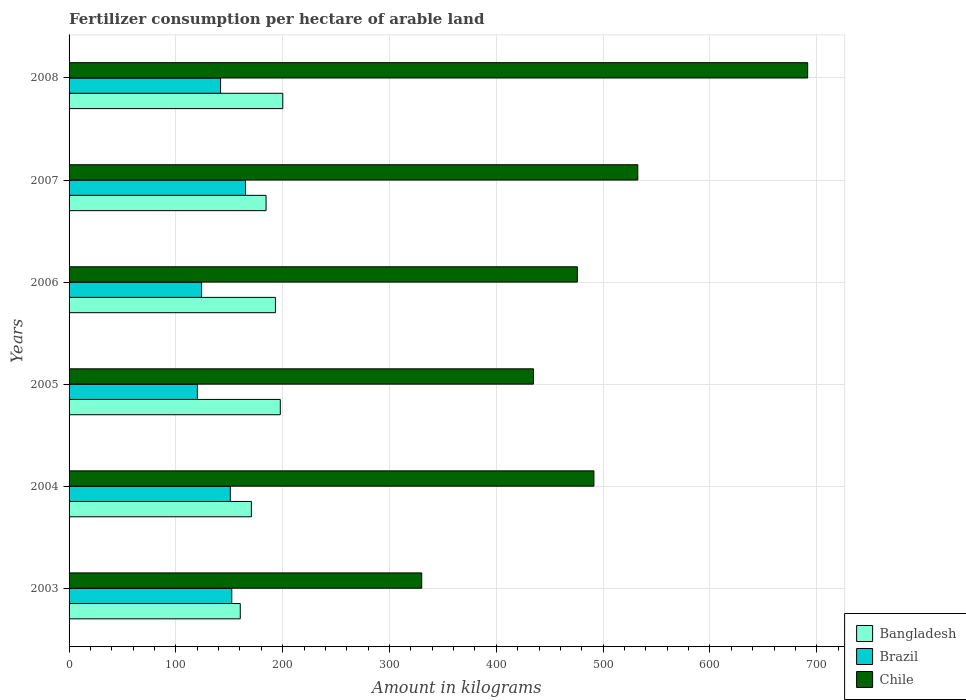How many different coloured bars are there?
Provide a succinct answer. 3. How many groups of bars are there?
Your answer should be very brief. 6. How many bars are there on the 6th tick from the top?
Your response must be concise. 3. What is the label of the 4th group of bars from the top?
Make the answer very short. 2005. What is the amount of fertilizer consumption in Bangladesh in 2004?
Offer a very short reply. 170.67. Across all years, what is the maximum amount of fertilizer consumption in Chile?
Provide a short and direct response. 691.46. Across all years, what is the minimum amount of fertilizer consumption in Chile?
Ensure brevity in your answer.  330.14. In which year was the amount of fertilizer consumption in Brazil maximum?
Your response must be concise. 2007. What is the total amount of fertilizer consumption in Brazil in the graph?
Give a very brief answer. 854.39. What is the difference between the amount of fertilizer consumption in Chile in 2003 and that in 2008?
Make the answer very short. -361.31. What is the difference between the amount of fertilizer consumption in Chile in 2004 and the amount of fertilizer consumption in Brazil in 2003?
Keep it short and to the point. 339.05. What is the average amount of fertilizer consumption in Chile per year?
Offer a terse response. 492.66. In the year 2008, what is the difference between the amount of fertilizer consumption in Bangladesh and amount of fertilizer consumption in Chile?
Your answer should be compact. -491.39. In how many years, is the amount of fertilizer consumption in Brazil greater than 140 kg?
Offer a terse response. 4. What is the ratio of the amount of fertilizer consumption in Chile in 2006 to that in 2007?
Offer a terse response. 0.89. Is the amount of fertilizer consumption in Chile in 2006 less than that in 2008?
Offer a very short reply. Yes. Is the difference between the amount of fertilizer consumption in Bangladesh in 2006 and 2008 greater than the difference between the amount of fertilizer consumption in Chile in 2006 and 2008?
Give a very brief answer. Yes. What is the difference between the highest and the second highest amount of fertilizer consumption in Chile?
Give a very brief answer. 159.04. What is the difference between the highest and the lowest amount of fertilizer consumption in Chile?
Your answer should be compact. 361.31. In how many years, is the amount of fertilizer consumption in Brazil greater than the average amount of fertilizer consumption in Brazil taken over all years?
Provide a short and direct response. 3. What does the 3rd bar from the top in 2004 represents?
Your answer should be very brief. Bangladesh. What does the 2nd bar from the bottom in 2004 represents?
Your response must be concise. Brazil. Is it the case that in every year, the sum of the amount of fertilizer consumption in Brazil and amount of fertilizer consumption in Bangladesh is greater than the amount of fertilizer consumption in Chile?
Keep it short and to the point. No. How many bars are there?
Give a very brief answer. 18. Are all the bars in the graph horizontal?
Your response must be concise. Yes. How many years are there in the graph?
Ensure brevity in your answer.  6. Are the values on the major ticks of X-axis written in scientific E-notation?
Ensure brevity in your answer.  No. Does the graph contain grids?
Your answer should be compact. Yes. Where does the legend appear in the graph?
Your response must be concise. Bottom right. How many legend labels are there?
Make the answer very short. 3. How are the legend labels stacked?
Your response must be concise. Vertical. What is the title of the graph?
Your response must be concise. Fertilizer consumption per hectare of arable land. What is the label or title of the X-axis?
Your response must be concise. Amount in kilograms. What is the label or title of the Y-axis?
Give a very brief answer. Years. What is the Amount in kilograms in Bangladesh in 2003?
Provide a succinct answer. 160.27. What is the Amount in kilograms of Brazil in 2003?
Provide a succinct answer. 152.31. What is the Amount in kilograms of Chile in 2003?
Your answer should be very brief. 330.14. What is the Amount in kilograms of Bangladesh in 2004?
Ensure brevity in your answer.  170.67. What is the Amount in kilograms of Brazil in 2004?
Make the answer very short. 150.95. What is the Amount in kilograms of Chile in 2004?
Keep it short and to the point. 491.35. What is the Amount in kilograms in Bangladesh in 2005?
Offer a very short reply. 197.75. What is the Amount in kilograms of Brazil in 2005?
Your response must be concise. 120.1. What is the Amount in kilograms of Chile in 2005?
Keep it short and to the point. 434.76. What is the Amount in kilograms of Bangladesh in 2006?
Give a very brief answer. 193.19. What is the Amount in kilograms of Brazil in 2006?
Give a very brief answer. 124.03. What is the Amount in kilograms in Chile in 2006?
Your response must be concise. 475.81. What is the Amount in kilograms in Bangladesh in 2007?
Keep it short and to the point. 184.41. What is the Amount in kilograms of Brazil in 2007?
Provide a short and direct response. 165.17. What is the Amount in kilograms in Chile in 2007?
Keep it short and to the point. 532.41. What is the Amount in kilograms in Bangladesh in 2008?
Keep it short and to the point. 200.06. What is the Amount in kilograms in Brazil in 2008?
Make the answer very short. 141.84. What is the Amount in kilograms of Chile in 2008?
Provide a short and direct response. 691.46. Across all years, what is the maximum Amount in kilograms in Bangladesh?
Give a very brief answer. 200.06. Across all years, what is the maximum Amount in kilograms in Brazil?
Your answer should be very brief. 165.17. Across all years, what is the maximum Amount in kilograms of Chile?
Give a very brief answer. 691.46. Across all years, what is the minimum Amount in kilograms in Bangladesh?
Your answer should be very brief. 160.27. Across all years, what is the minimum Amount in kilograms in Brazil?
Give a very brief answer. 120.1. Across all years, what is the minimum Amount in kilograms in Chile?
Keep it short and to the point. 330.14. What is the total Amount in kilograms in Bangladesh in the graph?
Offer a terse response. 1106.35. What is the total Amount in kilograms in Brazil in the graph?
Offer a terse response. 854.39. What is the total Amount in kilograms in Chile in the graph?
Your answer should be compact. 2955.94. What is the difference between the Amount in kilograms of Bangladesh in 2003 and that in 2004?
Offer a very short reply. -10.4. What is the difference between the Amount in kilograms in Brazil in 2003 and that in 2004?
Your answer should be very brief. 1.36. What is the difference between the Amount in kilograms of Chile in 2003 and that in 2004?
Offer a terse response. -161.21. What is the difference between the Amount in kilograms in Bangladesh in 2003 and that in 2005?
Provide a short and direct response. -37.48. What is the difference between the Amount in kilograms of Brazil in 2003 and that in 2005?
Provide a succinct answer. 32.2. What is the difference between the Amount in kilograms of Chile in 2003 and that in 2005?
Your answer should be compact. -104.62. What is the difference between the Amount in kilograms of Bangladesh in 2003 and that in 2006?
Your answer should be compact. -32.92. What is the difference between the Amount in kilograms in Brazil in 2003 and that in 2006?
Your answer should be compact. 28.27. What is the difference between the Amount in kilograms in Chile in 2003 and that in 2006?
Keep it short and to the point. -145.67. What is the difference between the Amount in kilograms in Bangladesh in 2003 and that in 2007?
Make the answer very short. -24.14. What is the difference between the Amount in kilograms of Brazil in 2003 and that in 2007?
Keep it short and to the point. -12.86. What is the difference between the Amount in kilograms of Chile in 2003 and that in 2007?
Make the answer very short. -202.27. What is the difference between the Amount in kilograms of Bangladesh in 2003 and that in 2008?
Provide a short and direct response. -39.8. What is the difference between the Amount in kilograms of Brazil in 2003 and that in 2008?
Ensure brevity in your answer.  10.47. What is the difference between the Amount in kilograms of Chile in 2003 and that in 2008?
Keep it short and to the point. -361.31. What is the difference between the Amount in kilograms of Bangladesh in 2004 and that in 2005?
Provide a short and direct response. -27.08. What is the difference between the Amount in kilograms in Brazil in 2004 and that in 2005?
Offer a very short reply. 30.85. What is the difference between the Amount in kilograms in Chile in 2004 and that in 2005?
Your response must be concise. 56.59. What is the difference between the Amount in kilograms of Bangladesh in 2004 and that in 2006?
Your answer should be very brief. -22.52. What is the difference between the Amount in kilograms of Brazil in 2004 and that in 2006?
Your answer should be compact. 26.91. What is the difference between the Amount in kilograms of Chile in 2004 and that in 2006?
Give a very brief answer. 15.54. What is the difference between the Amount in kilograms of Bangladesh in 2004 and that in 2007?
Your response must be concise. -13.74. What is the difference between the Amount in kilograms in Brazil in 2004 and that in 2007?
Provide a succinct answer. -14.22. What is the difference between the Amount in kilograms in Chile in 2004 and that in 2007?
Make the answer very short. -41.06. What is the difference between the Amount in kilograms in Bangladesh in 2004 and that in 2008?
Offer a very short reply. -29.39. What is the difference between the Amount in kilograms in Brazil in 2004 and that in 2008?
Offer a very short reply. 9.11. What is the difference between the Amount in kilograms of Chile in 2004 and that in 2008?
Your response must be concise. -200.1. What is the difference between the Amount in kilograms of Bangladesh in 2005 and that in 2006?
Your answer should be compact. 4.56. What is the difference between the Amount in kilograms in Brazil in 2005 and that in 2006?
Ensure brevity in your answer.  -3.93. What is the difference between the Amount in kilograms in Chile in 2005 and that in 2006?
Ensure brevity in your answer.  -41.05. What is the difference between the Amount in kilograms of Bangladesh in 2005 and that in 2007?
Give a very brief answer. 13.34. What is the difference between the Amount in kilograms of Brazil in 2005 and that in 2007?
Ensure brevity in your answer.  -45.07. What is the difference between the Amount in kilograms in Chile in 2005 and that in 2007?
Make the answer very short. -97.65. What is the difference between the Amount in kilograms of Bangladesh in 2005 and that in 2008?
Give a very brief answer. -2.32. What is the difference between the Amount in kilograms of Brazil in 2005 and that in 2008?
Offer a very short reply. -21.74. What is the difference between the Amount in kilograms in Chile in 2005 and that in 2008?
Offer a terse response. -256.69. What is the difference between the Amount in kilograms in Bangladesh in 2006 and that in 2007?
Offer a terse response. 8.78. What is the difference between the Amount in kilograms in Brazil in 2006 and that in 2007?
Make the answer very short. -41.14. What is the difference between the Amount in kilograms of Chile in 2006 and that in 2007?
Your answer should be very brief. -56.6. What is the difference between the Amount in kilograms in Bangladesh in 2006 and that in 2008?
Offer a very short reply. -6.87. What is the difference between the Amount in kilograms of Brazil in 2006 and that in 2008?
Offer a very short reply. -17.81. What is the difference between the Amount in kilograms of Chile in 2006 and that in 2008?
Keep it short and to the point. -215.64. What is the difference between the Amount in kilograms of Bangladesh in 2007 and that in 2008?
Make the answer very short. -15.65. What is the difference between the Amount in kilograms in Brazil in 2007 and that in 2008?
Your response must be concise. 23.33. What is the difference between the Amount in kilograms in Chile in 2007 and that in 2008?
Your response must be concise. -159.04. What is the difference between the Amount in kilograms in Bangladesh in 2003 and the Amount in kilograms in Brazil in 2004?
Your response must be concise. 9.32. What is the difference between the Amount in kilograms in Bangladesh in 2003 and the Amount in kilograms in Chile in 2004?
Your answer should be very brief. -331.09. What is the difference between the Amount in kilograms of Brazil in 2003 and the Amount in kilograms of Chile in 2004?
Offer a terse response. -339.05. What is the difference between the Amount in kilograms in Bangladesh in 2003 and the Amount in kilograms in Brazil in 2005?
Provide a succinct answer. 40.17. What is the difference between the Amount in kilograms of Bangladesh in 2003 and the Amount in kilograms of Chile in 2005?
Give a very brief answer. -274.49. What is the difference between the Amount in kilograms in Brazil in 2003 and the Amount in kilograms in Chile in 2005?
Your answer should be very brief. -282.46. What is the difference between the Amount in kilograms in Bangladesh in 2003 and the Amount in kilograms in Brazil in 2006?
Provide a succinct answer. 36.23. What is the difference between the Amount in kilograms of Bangladesh in 2003 and the Amount in kilograms of Chile in 2006?
Your answer should be compact. -315.55. What is the difference between the Amount in kilograms in Brazil in 2003 and the Amount in kilograms in Chile in 2006?
Provide a succinct answer. -323.51. What is the difference between the Amount in kilograms of Bangladesh in 2003 and the Amount in kilograms of Brazil in 2007?
Offer a very short reply. -4.9. What is the difference between the Amount in kilograms of Bangladesh in 2003 and the Amount in kilograms of Chile in 2007?
Keep it short and to the point. -372.15. What is the difference between the Amount in kilograms of Brazil in 2003 and the Amount in kilograms of Chile in 2007?
Give a very brief answer. -380.11. What is the difference between the Amount in kilograms of Bangladesh in 2003 and the Amount in kilograms of Brazil in 2008?
Ensure brevity in your answer.  18.43. What is the difference between the Amount in kilograms in Bangladesh in 2003 and the Amount in kilograms in Chile in 2008?
Provide a short and direct response. -531.19. What is the difference between the Amount in kilograms of Brazil in 2003 and the Amount in kilograms of Chile in 2008?
Provide a short and direct response. -539.15. What is the difference between the Amount in kilograms in Bangladesh in 2004 and the Amount in kilograms in Brazil in 2005?
Provide a short and direct response. 50.57. What is the difference between the Amount in kilograms of Bangladesh in 2004 and the Amount in kilograms of Chile in 2005?
Ensure brevity in your answer.  -264.09. What is the difference between the Amount in kilograms in Brazil in 2004 and the Amount in kilograms in Chile in 2005?
Offer a terse response. -283.82. What is the difference between the Amount in kilograms of Bangladesh in 2004 and the Amount in kilograms of Brazil in 2006?
Give a very brief answer. 46.64. What is the difference between the Amount in kilograms of Bangladesh in 2004 and the Amount in kilograms of Chile in 2006?
Provide a short and direct response. -305.14. What is the difference between the Amount in kilograms of Brazil in 2004 and the Amount in kilograms of Chile in 2006?
Provide a short and direct response. -324.87. What is the difference between the Amount in kilograms in Bangladesh in 2004 and the Amount in kilograms in Brazil in 2007?
Ensure brevity in your answer.  5.5. What is the difference between the Amount in kilograms of Bangladesh in 2004 and the Amount in kilograms of Chile in 2007?
Keep it short and to the point. -361.74. What is the difference between the Amount in kilograms of Brazil in 2004 and the Amount in kilograms of Chile in 2007?
Offer a terse response. -381.47. What is the difference between the Amount in kilograms of Bangladesh in 2004 and the Amount in kilograms of Brazil in 2008?
Give a very brief answer. 28.83. What is the difference between the Amount in kilograms of Bangladesh in 2004 and the Amount in kilograms of Chile in 2008?
Ensure brevity in your answer.  -520.78. What is the difference between the Amount in kilograms in Brazil in 2004 and the Amount in kilograms in Chile in 2008?
Your answer should be very brief. -540.51. What is the difference between the Amount in kilograms in Bangladesh in 2005 and the Amount in kilograms in Brazil in 2006?
Ensure brevity in your answer.  73.72. What is the difference between the Amount in kilograms in Bangladesh in 2005 and the Amount in kilograms in Chile in 2006?
Give a very brief answer. -278.07. What is the difference between the Amount in kilograms in Brazil in 2005 and the Amount in kilograms in Chile in 2006?
Make the answer very short. -355.71. What is the difference between the Amount in kilograms in Bangladesh in 2005 and the Amount in kilograms in Brazil in 2007?
Your answer should be compact. 32.58. What is the difference between the Amount in kilograms in Bangladesh in 2005 and the Amount in kilograms in Chile in 2007?
Provide a succinct answer. -334.66. What is the difference between the Amount in kilograms in Brazil in 2005 and the Amount in kilograms in Chile in 2007?
Offer a terse response. -412.31. What is the difference between the Amount in kilograms of Bangladesh in 2005 and the Amount in kilograms of Brazil in 2008?
Offer a terse response. 55.91. What is the difference between the Amount in kilograms in Bangladesh in 2005 and the Amount in kilograms in Chile in 2008?
Provide a succinct answer. -493.71. What is the difference between the Amount in kilograms in Brazil in 2005 and the Amount in kilograms in Chile in 2008?
Make the answer very short. -571.36. What is the difference between the Amount in kilograms of Bangladesh in 2006 and the Amount in kilograms of Brazil in 2007?
Your answer should be compact. 28.02. What is the difference between the Amount in kilograms of Bangladesh in 2006 and the Amount in kilograms of Chile in 2007?
Your response must be concise. -339.22. What is the difference between the Amount in kilograms of Brazil in 2006 and the Amount in kilograms of Chile in 2007?
Make the answer very short. -408.38. What is the difference between the Amount in kilograms of Bangladesh in 2006 and the Amount in kilograms of Brazil in 2008?
Ensure brevity in your answer.  51.35. What is the difference between the Amount in kilograms of Bangladesh in 2006 and the Amount in kilograms of Chile in 2008?
Provide a short and direct response. -498.27. What is the difference between the Amount in kilograms of Brazil in 2006 and the Amount in kilograms of Chile in 2008?
Keep it short and to the point. -567.42. What is the difference between the Amount in kilograms in Bangladesh in 2007 and the Amount in kilograms in Brazil in 2008?
Give a very brief answer. 42.57. What is the difference between the Amount in kilograms of Bangladesh in 2007 and the Amount in kilograms of Chile in 2008?
Make the answer very short. -507.05. What is the difference between the Amount in kilograms of Brazil in 2007 and the Amount in kilograms of Chile in 2008?
Make the answer very short. -526.29. What is the average Amount in kilograms in Bangladesh per year?
Offer a very short reply. 184.39. What is the average Amount in kilograms in Brazil per year?
Give a very brief answer. 142.4. What is the average Amount in kilograms in Chile per year?
Provide a succinct answer. 492.66. In the year 2003, what is the difference between the Amount in kilograms in Bangladesh and Amount in kilograms in Brazil?
Keep it short and to the point. 7.96. In the year 2003, what is the difference between the Amount in kilograms in Bangladesh and Amount in kilograms in Chile?
Provide a succinct answer. -169.88. In the year 2003, what is the difference between the Amount in kilograms of Brazil and Amount in kilograms of Chile?
Offer a very short reply. -177.84. In the year 2004, what is the difference between the Amount in kilograms of Bangladesh and Amount in kilograms of Brazil?
Your answer should be very brief. 19.73. In the year 2004, what is the difference between the Amount in kilograms in Bangladesh and Amount in kilograms in Chile?
Offer a very short reply. -320.68. In the year 2004, what is the difference between the Amount in kilograms in Brazil and Amount in kilograms in Chile?
Keep it short and to the point. -340.41. In the year 2005, what is the difference between the Amount in kilograms in Bangladesh and Amount in kilograms in Brazil?
Offer a very short reply. 77.65. In the year 2005, what is the difference between the Amount in kilograms of Bangladesh and Amount in kilograms of Chile?
Offer a very short reply. -237.01. In the year 2005, what is the difference between the Amount in kilograms of Brazil and Amount in kilograms of Chile?
Your answer should be very brief. -314.66. In the year 2006, what is the difference between the Amount in kilograms of Bangladesh and Amount in kilograms of Brazil?
Ensure brevity in your answer.  69.16. In the year 2006, what is the difference between the Amount in kilograms in Bangladesh and Amount in kilograms in Chile?
Your answer should be very brief. -282.62. In the year 2006, what is the difference between the Amount in kilograms of Brazil and Amount in kilograms of Chile?
Provide a succinct answer. -351.78. In the year 2007, what is the difference between the Amount in kilograms of Bangladesh and Amount in kilograms of Brazil?
Your answer should be very brief. 19.24. In the year 2007, what is the difference between the Amount in kilograms of Bangladesh and Amount in kilograms of Chile?
Offer a very short reply. -348. In the year 2007, what is the difference between the Amount in kilograms in Brazil and Amount in kilograms in Chile?
Give a very brief answer. -367.24. In the year 2008, what is the difference between the Amount in kilograms in Bangladesh and Amount in kilograms in Brazil?
Provide a succinct answer. 58.23. In the year 2008, what is the difference between the Amount in kilograms of Bangladesh and Amount in kilograms of Chile?
Ensure brevity in your answer.  -491.39. In the year 2008, what is the difference between the Amount in kilograms of Brazil and Amount in kilograms of Chile?
Make the answer very short. -549.62. What is the ratio of the Amount in kilograms in Bangladesh in 2003 to that in 2004?
Keep it short and to the point. 0.94. What is the ratio of the Amount in kilograms in Chile in 2003 to that in 2004?
Make the answer very short. 0.67. What is the ratio of the Amount in kilograms in Bangladesh in 2003 to that in 2005?
Your response must be concise. 0.81. What is the ratio of the Amount in kilograms in Brazil in 2003 to that in 2005?
Provide a short and direct response. 1.27. What is the ratio of the Amount in kilograms of Chile in 2003 to that in 2005?
Offer a very short reply. 0.76. What is the ratio of the Amount in kilograms of Bangladesh in 2003 to that in 2006?
Offer a very short reply. 0.83. What is the ratio of the Amount in kilograms of Brazil in 2003 to that in 2006?
Your answer should be very brief. 1.23. What is the ratio of the Amount in kilograms of Chile in 2003 to that in 2006?
Your answer should be very brief. 0.69. What is the ratio of the Amount in kilograms of Bangladesh in 2003 to that in 2007?
Give a very brief answer. 0.87. What is the ratio of the Amount in kilograms of Brazil in 2003 to that in 2007?
Keep it short and to the point. 0.92. What is the ratio of the Amount in kilograms in Chile in 2003 to that in 2007?
Make the answer very short. 0.62. What is the ratio of the Amount in kilograms of Bangladesh in 2003 to that in 2008?
Provide a succinct answer. 0.8. What is the ratio of the Amount in kilograms of Brazil in 2003 to that in 2008?
Keep it short and to the point. 1.07. What is the ratio of the Amount in kilograms of Chile in 2003 to that in 2008?
Your response must be concise. 0.48. What is the ratio of the Amount in kilograms of Bangladesh in 2004 to that in 2005?
Provide a short and direct response. 0.86. What is the ratio of the Amount in kilograms of Brazil in 2004 to that in 2005?
Your answer should be very brief. 1.26. What is the ratio of the Amount in kilograms of Chile in 2004 to that in 2005?
Offer a terse response. 1.13. What is the ratio of the Amount in kilograms in Bangladesh in 2004 to that in 2006?
Offer a terse response. 0.88. What is the ratio of the Amount in kilograms in Brazil in 2004 to that in 2006?
Offer a very short reply. 1.22. What is the ratio of the Amount in kilograms in Chile in 2004 to that in 2006?
Ensure brevity in your answer.  1.03. What is the ratio of the Amount in kilograms in Bangladesh in 2004 to that in 2007?
Your answer should be compact. 0.93. What is the ratio of the Amount in kilograms of Brazil in 2004 to that in 2007?
Provide a succinct answer. 0.91. What is the ratio of the Amount in kilograms in Chile in 2004 to that in 2007?
Offer a very short reply. 0.92. What is the ratio of the Amount in kilograms of Bangladesh in 2004 to that in 2008?
Your answer should be very brief. 0.85. What is the ratio of the Amount in kilograms in Brazil in 2004 to that in 2008?
Ensure brevity in your answer.  1.06. What is the ratio of the Amount in kilograms in Chile in 2004 to that in 2008?
Keep it short and to the point. 0.71. What is the ratio of the Amount in kilograms of Bangladesh in 2005 to that in 2006?
Your answer should be compact. 1.02. What is the ratio of the Amount in kilograms in Brazil in 2005 to that in 2006?
Your answer should be very brief. 0.97. What is the ratio of the Amount in kilograms of Chile in 2005 to that in 2006?
Your answer should be compact. 0.91. What is the ratio of the Amount in kilograms in Bangladesh in 2005 to that in 2007?
Offer a terse response. 1.07. What is the ratio of the Amount in kilograms of Brazil in 2005 to that in 2007?
Offer a very short reply. 0.73. What is the ratio of the Amount in kilograms of Chile in 2005 to that in 2007?
Ensure brevity in your answer.  0.82. What is the ratio of the Amount in kilograms in Bangladesh in 2005 to that in 2008?
Your response must be concise. 0.99. What is the ratio of the Amount in kilograms of Brazil in 2005 to that in 2008?
Keep it short and to the point. 0.85. What is the ratio of the Amount in kilograms in Chile in 2005 to that in 2008?
Your response must be concise. 0.63. What is the ratio of the Amount in kilograms of Bangladesh in 2006 to that in 2007?
Offer a terse response. 1.05. What is the ratio of the Amount in kilograms in Brazil in 2006 to that in 2007?
Provide a short and direct response. 0.75. What is the ratio of the Amount in kilograms in Chile in 2006 to that in 2007?
Keep it short and to the point. 0.89. What is the ratio of the Amount in kilograms of Bangladesh in 2006 to that in 2008?
Give a very brief answer. 0.97. What is the ratio of the Amount in kilograms in Brazil in 2006 to that in 2008?
Provide a succinct answer. 0.87. What is the ratio of the Amount in kilograms in Chile in 2006 to that in 2008?
Give a very brief answer. 0.69. What is the ratio of the Amount in kilograms in Bangladesh in 2007 to that in 2008?
Keep it short and to the point. 0.92. What is the ratio of the Amount in kilograms in Brazil in 2007 to that in 2008?
Make the answer very short. 1.16. What is the ratio of the Amount in kilograms of Chile in 2007 to that in 2008?
Your answer should be compact. 0.77. What is the difference between the highest and the second highest Amount in kilograms of Bangladesh?
Offer a terse response. 2.32. What is the difference between the highest and the second highest Amount in kilograms in Brazil?
Give a very brief answer. 12.86. What is the difference between the highest and the second highest Amount in kilograms of Chile?
Provide a short and direct response. 159.04. What is the difference between the highest and the lowest Amount in kilograms of Bangladesh?
Keep it short and to the point. 39.8. What is the difference between the highest and the lowest Amount in kilograms in Brazil?
Give a very brief answer. 45.07. What is the difference between the highest and the lowest Amount in kilograms of Chile?
Offer a very short reply. 361.31. 